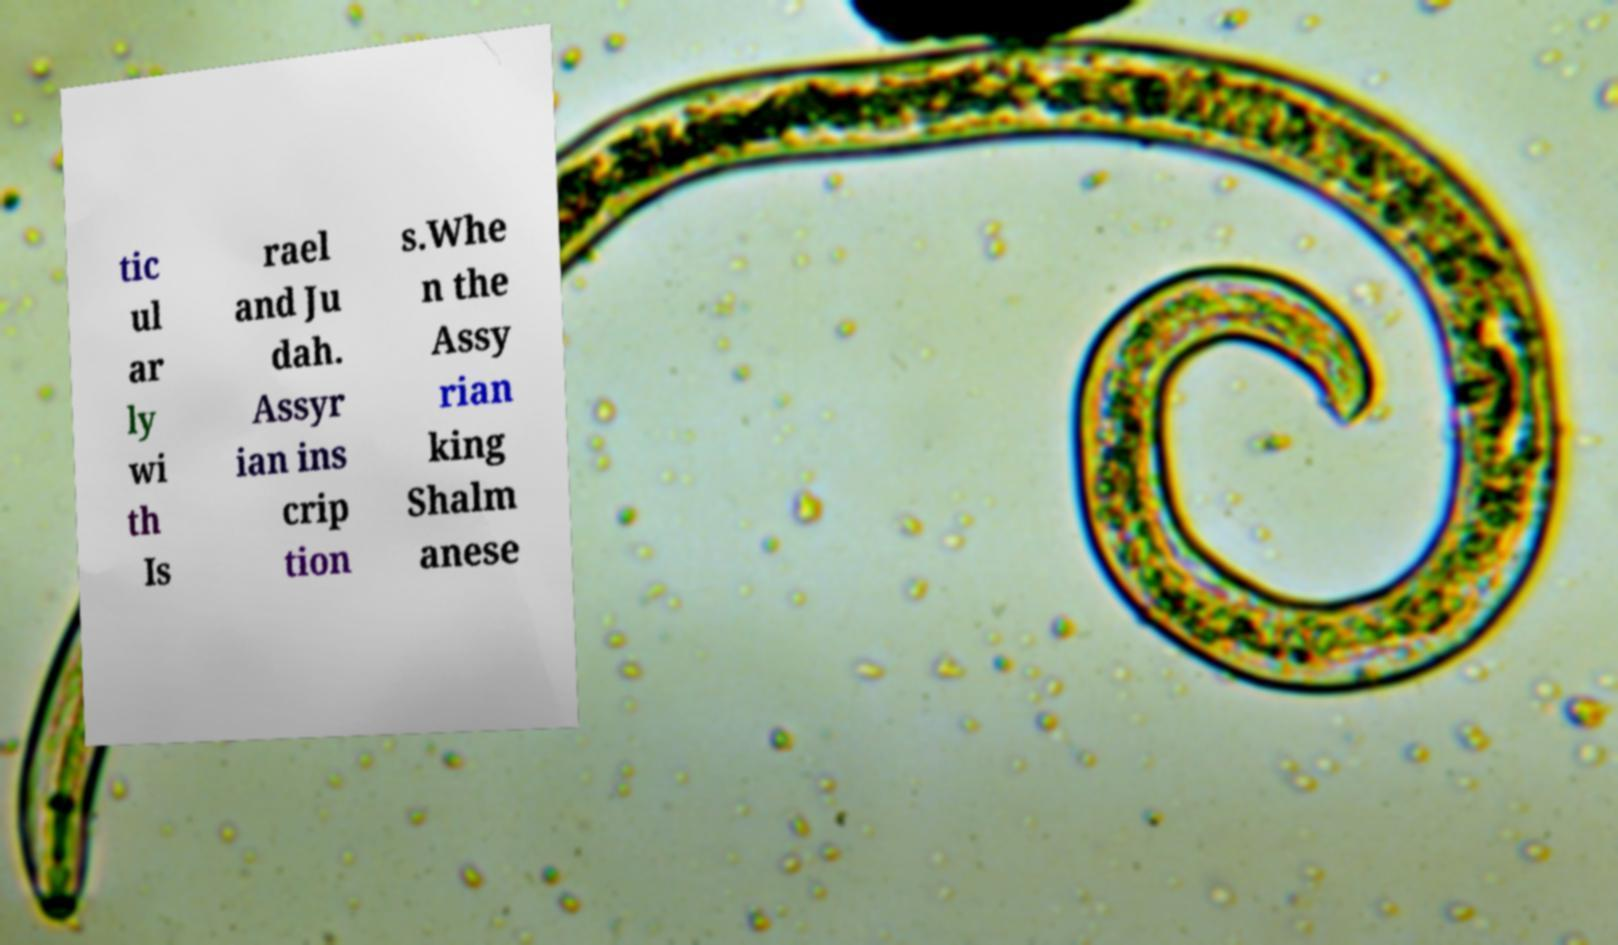Please read and relay the text visible in this image. What does it say? tic ul ar ly wi th Is rael and Ju dah. Assyr ian ins crip tion s.Whe n the Assy rian king Shalm anese 